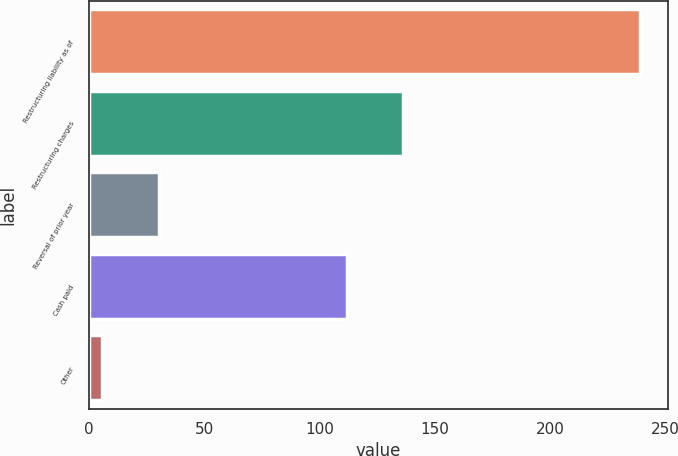<chart> <loc_0><loc_0><loc_500><loc_500><bar_chart><fcel>Restructuring liability as of<fcel>Restructuring charges<fcel>Reversal of prior year<fcel>Cash paid<fcel>Other<nl><fcel>239<fcel>136.3<fcel>30.3<fcel>112<fcel>6<nl></chart> 